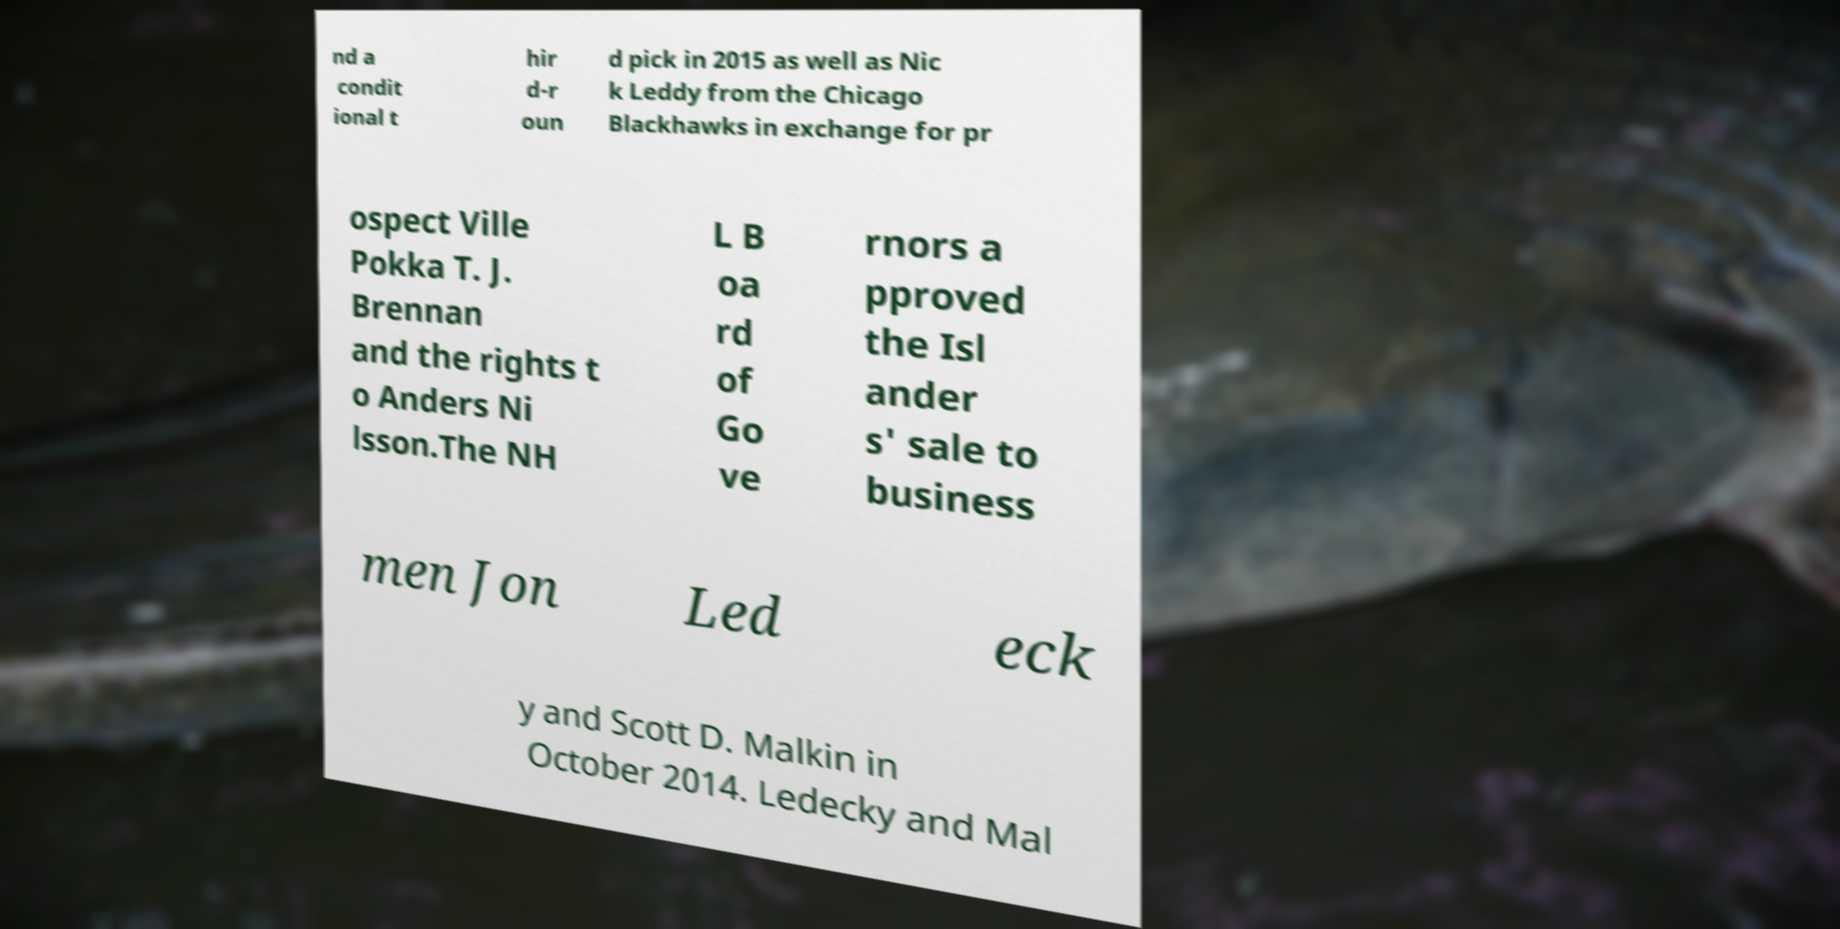For documentation purposes, I need the text within this image transcribed. Could you provide that? nd a condit ional t hir d-r oun d pick in 2015 as well as Nic k Leddy from the Chicago Blackhawks in exchange for pr ospect Ville Pokka T. J. Brennan and the rights t o Anders Ni lsson.The NH L B oa rd of Go ve rnors a pproved the Isl ander s' sale to business men Jon Led eck y and Scott D. Malkin in October 2014. Ledecky and Mal 